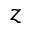<formula> <loc_0><loc_0><loc_500><loc_500>z</formula> 